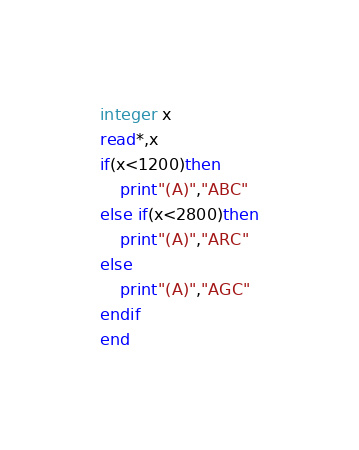<code> <loc_0><loc_0><loc_500><loc_500><_FORTRAN_>integer x
read*,x
if(x<1200)then
	print"(A)","ABC"
else if(x<2800)then
	print"(A)","ARC"
else
	print"(A)","AGC"
endif
end</code> 